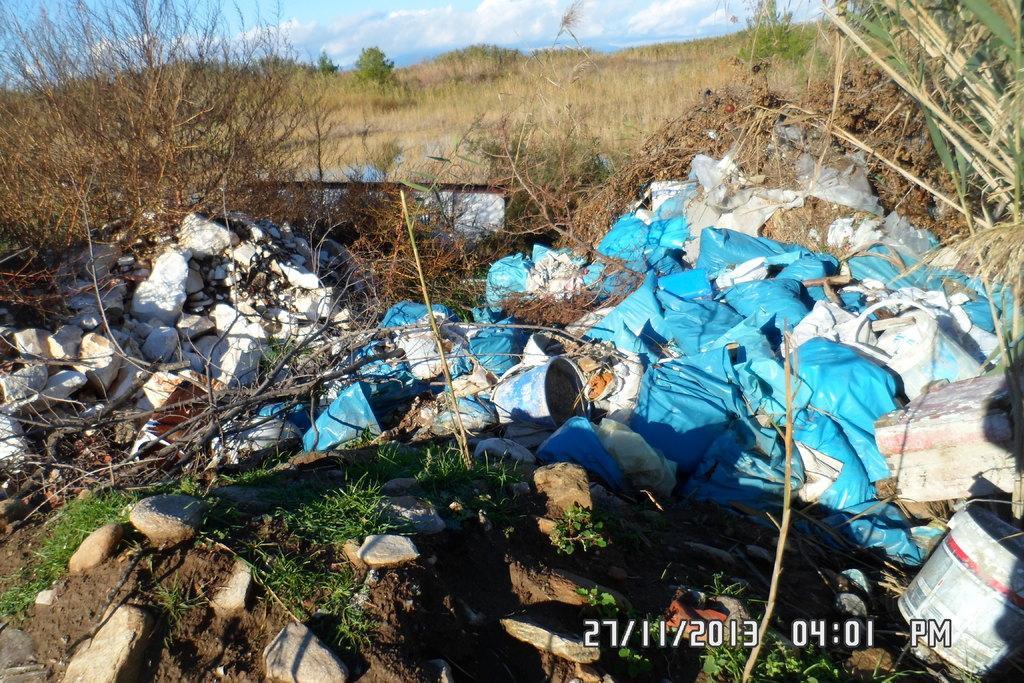Describe this image in one or two sentences. In this picture there are bags, buckets and stones in the foreground. At the back there are trees. At the top there is sky and there are clouds. 